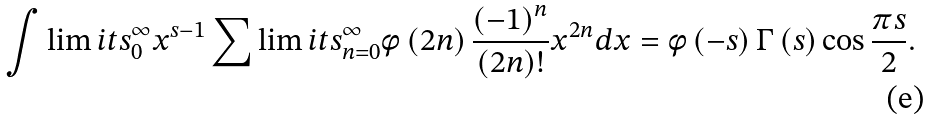<formula> <loc_0><loc_0><loc_500><loc_500>\int \lim i t s _ { 0 } ^ { \infty } { { x ^ { s - 1 } } \sum \lim i t s _ { n = 0 } ^ { \infty } { \phi \left ( { 2 n } \right ) \frac { { { { \left ( { - 1 } \right ) } ^ { n } } } } { { \left ( { 2 n } \right ) ! } } { x ^ { 2 n } } d x = \phi \left ( { - s } \right ) \Gamma \left ( s \right ) \cos \frac { \pi s } { 2 } } } .</formula> 